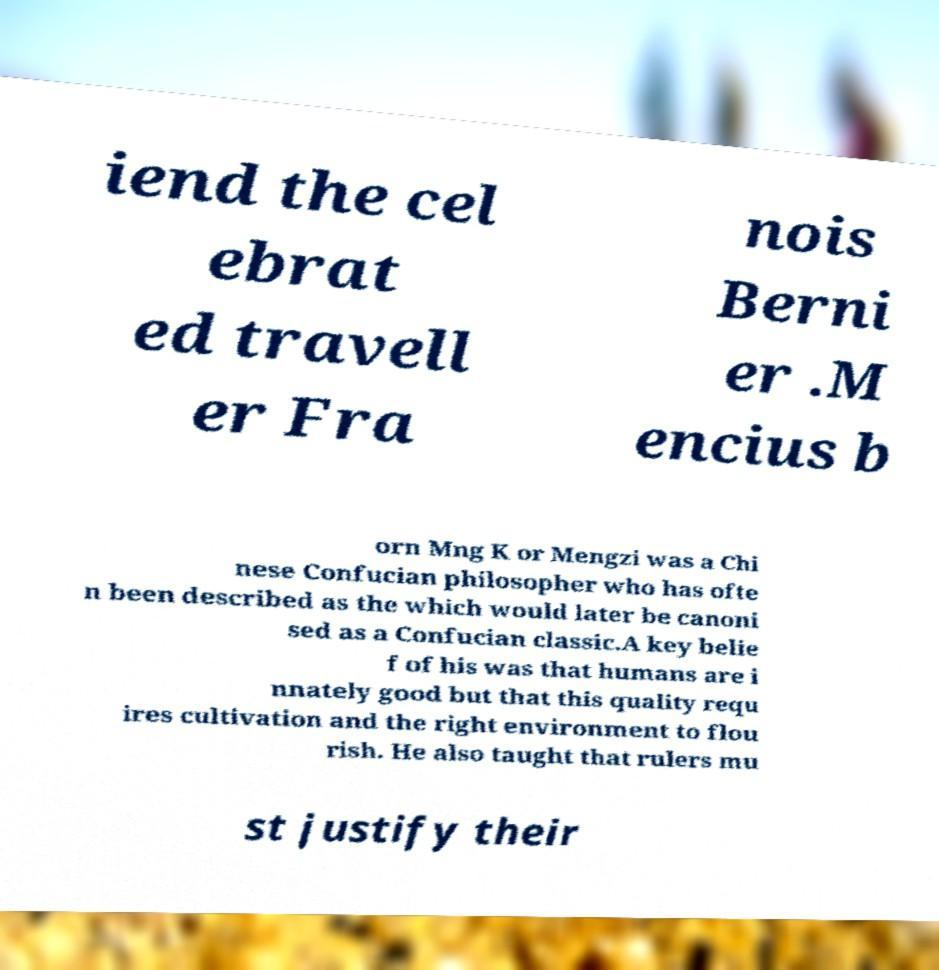For documentation purposes, I need the text within this image transcribed. Could you provide that? iend the cel ebrat ed travell er Fra nois Berni er .M encius b orn Mng K or Mengzi was a Chi nese Confucian philosopher who has ofte n been described as the which would later be canoni sed as a Confucian classic.A key belie f of his was that humans are i nnately good but that this quality requ ires cultivation and the right environment to flou rish. He also taught that rulers mu st justify their 